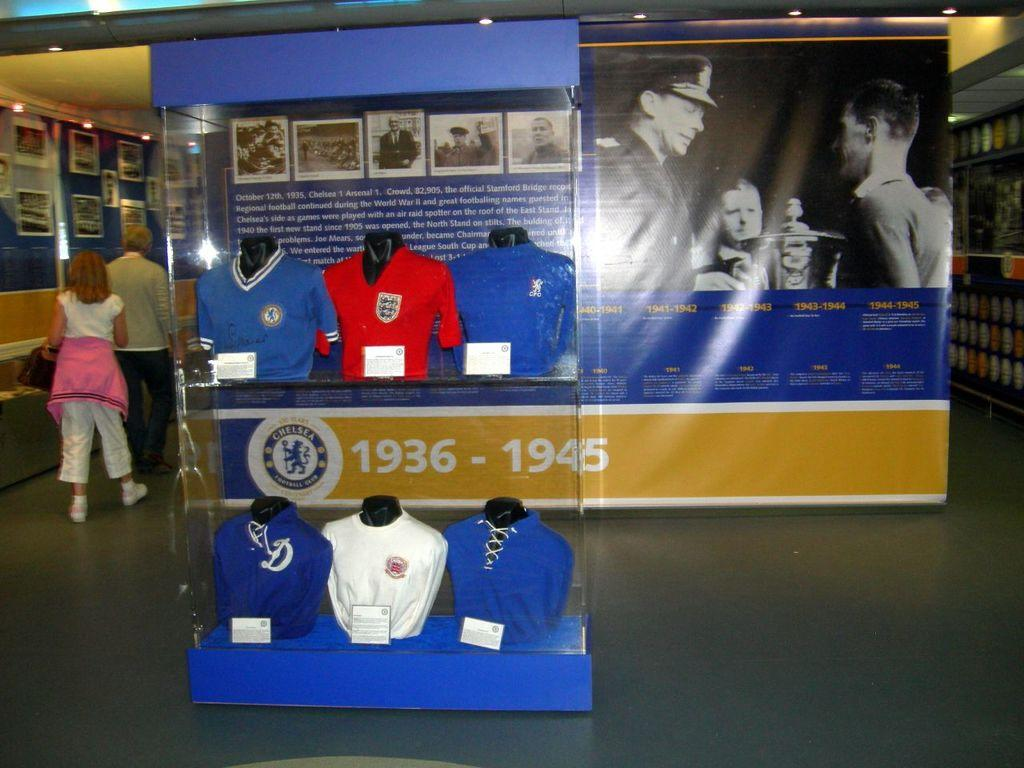<image>
Share a concise interpretation of the image provided. A display shows the years 1936-1945 and has several shirts in it. 